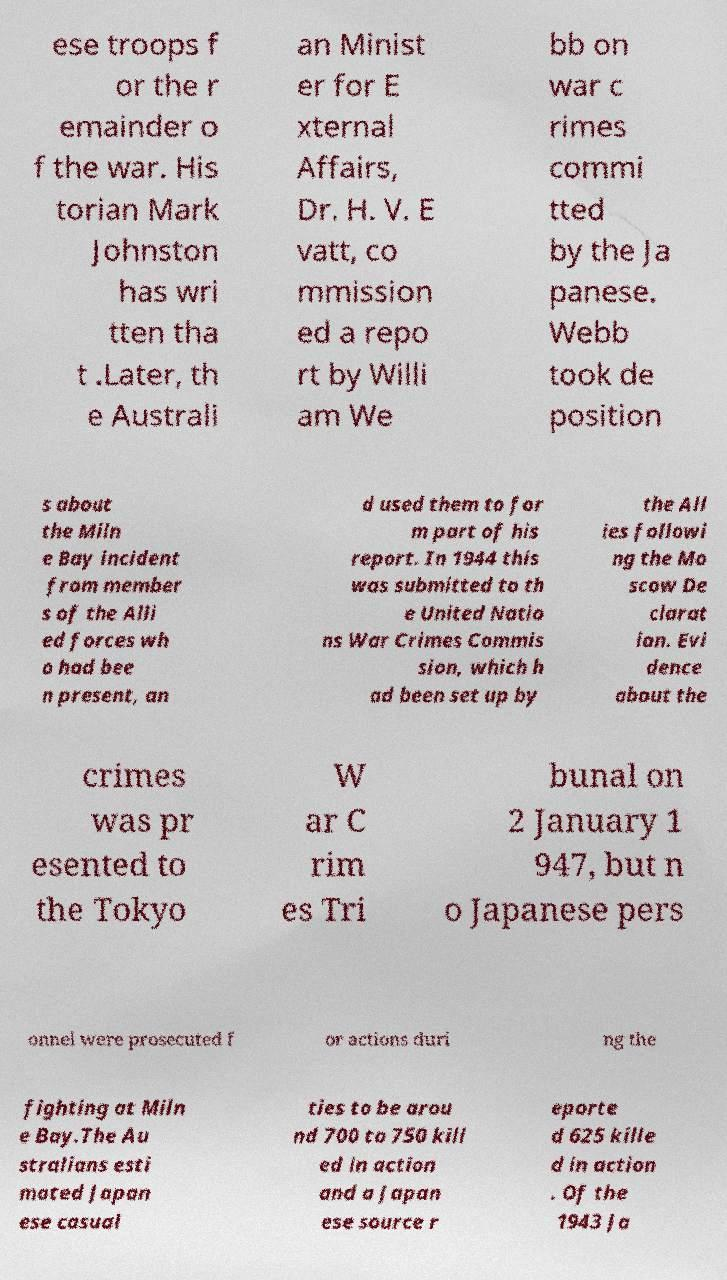Could you assist in decoding the text presented in this image and type it out clearly? ese troops f or the r emainder o f the war. His torian Mark Johnston has wri tten tha t .Later, th e Australi an Minist er for E xternal Affairs, Dr. H. V. E vatt, co mmission ed a repo rt by Willi am We bb on war c rimes commi tted by the Ja panese. Webb took de position s about the Miln e Bay incident from member s of the Alli ed forces wh o had bee n present, an d used them to for m part of his report. In 1944 this was submitted to th e United Natio ns War Crimes Commis sion, which h ad been set up by the All ies followi ng the Mo scow De clarat ion. Evi dence about the crimes was pr esented to the Tokyo W ar C rim es Tri bunal on 2 January 1 947, but n o Japanese pers onnel were prosecuted f or actions duri ng the fighting at Miln e Bay.The Au stralians esti mated Japan ese casual ties to be arou nd 700 to 750 kill ed in action and a Japan ese source r eporte d 625 kille d in action . Of the 1943 Ja 